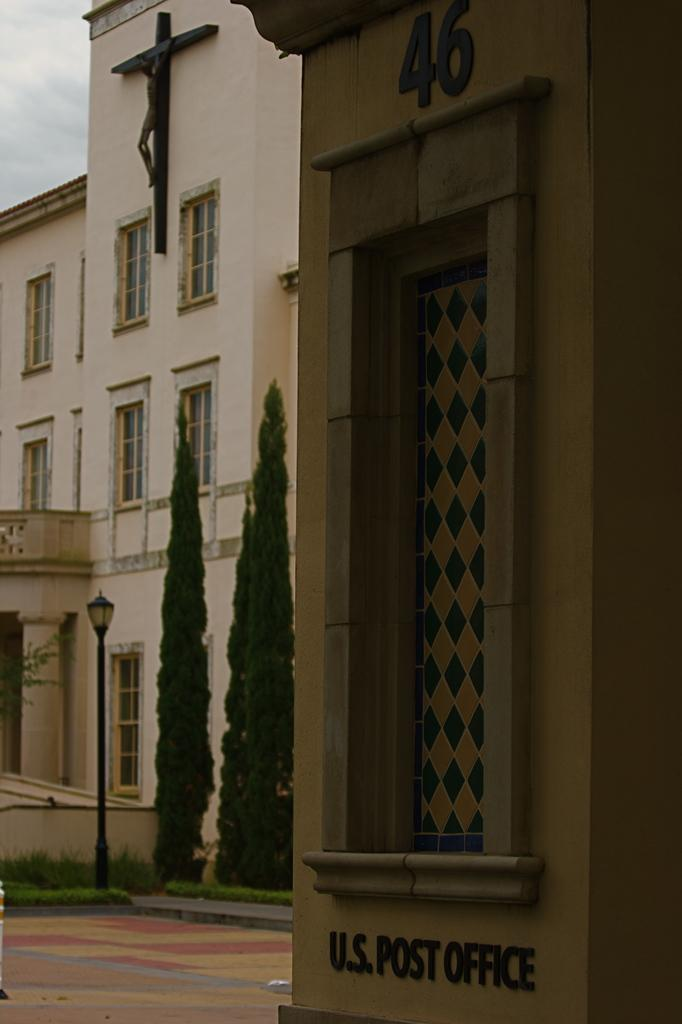What type of structures can be seen in the image? There are buildings in the image. What architectural feature can be seen on the buildings? There are windows in the image. What is the tall, vertical object in the image? There is a light pole in the image. What type of vegetation is present in the image? There are trees in the image. What type of artwork is present in the image? There is a statue in the image. What is the condition of the sky in the image? The sky is cloudy in the image. What type of punishment is being carried out on the statue in the image? There is no punishment being carried out on the statue in the image; it is a stationary artwork. What type of stick is being used to draw the picture in the image? There is no picture being drawn in the image, nor is there any stick present. 